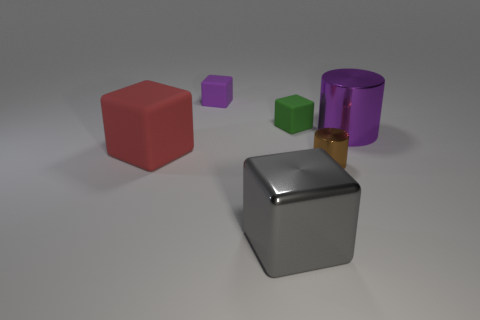Subtract all red blocks. How many blocks are left? 3 Add 2 small green rubber things. How many objects exist? 8 Subtract all gray cubes. How many cubes are left? 3 Subtract all blocks. How many objects are left? 2 Subtract 0 yellow blocks. How many objects are left? 6 Subtract all green cylinders. Subtract all red blocks. How many cylinders are left? 2 Subtract all small cyan matte spheres. Subtract all large gray things. How many objects are left? 5 Add 3 matte blocks. How many matte blocks are left? 6 Add 2 big blue matte cylinders. How many big blue matte cylinders exist? 2 